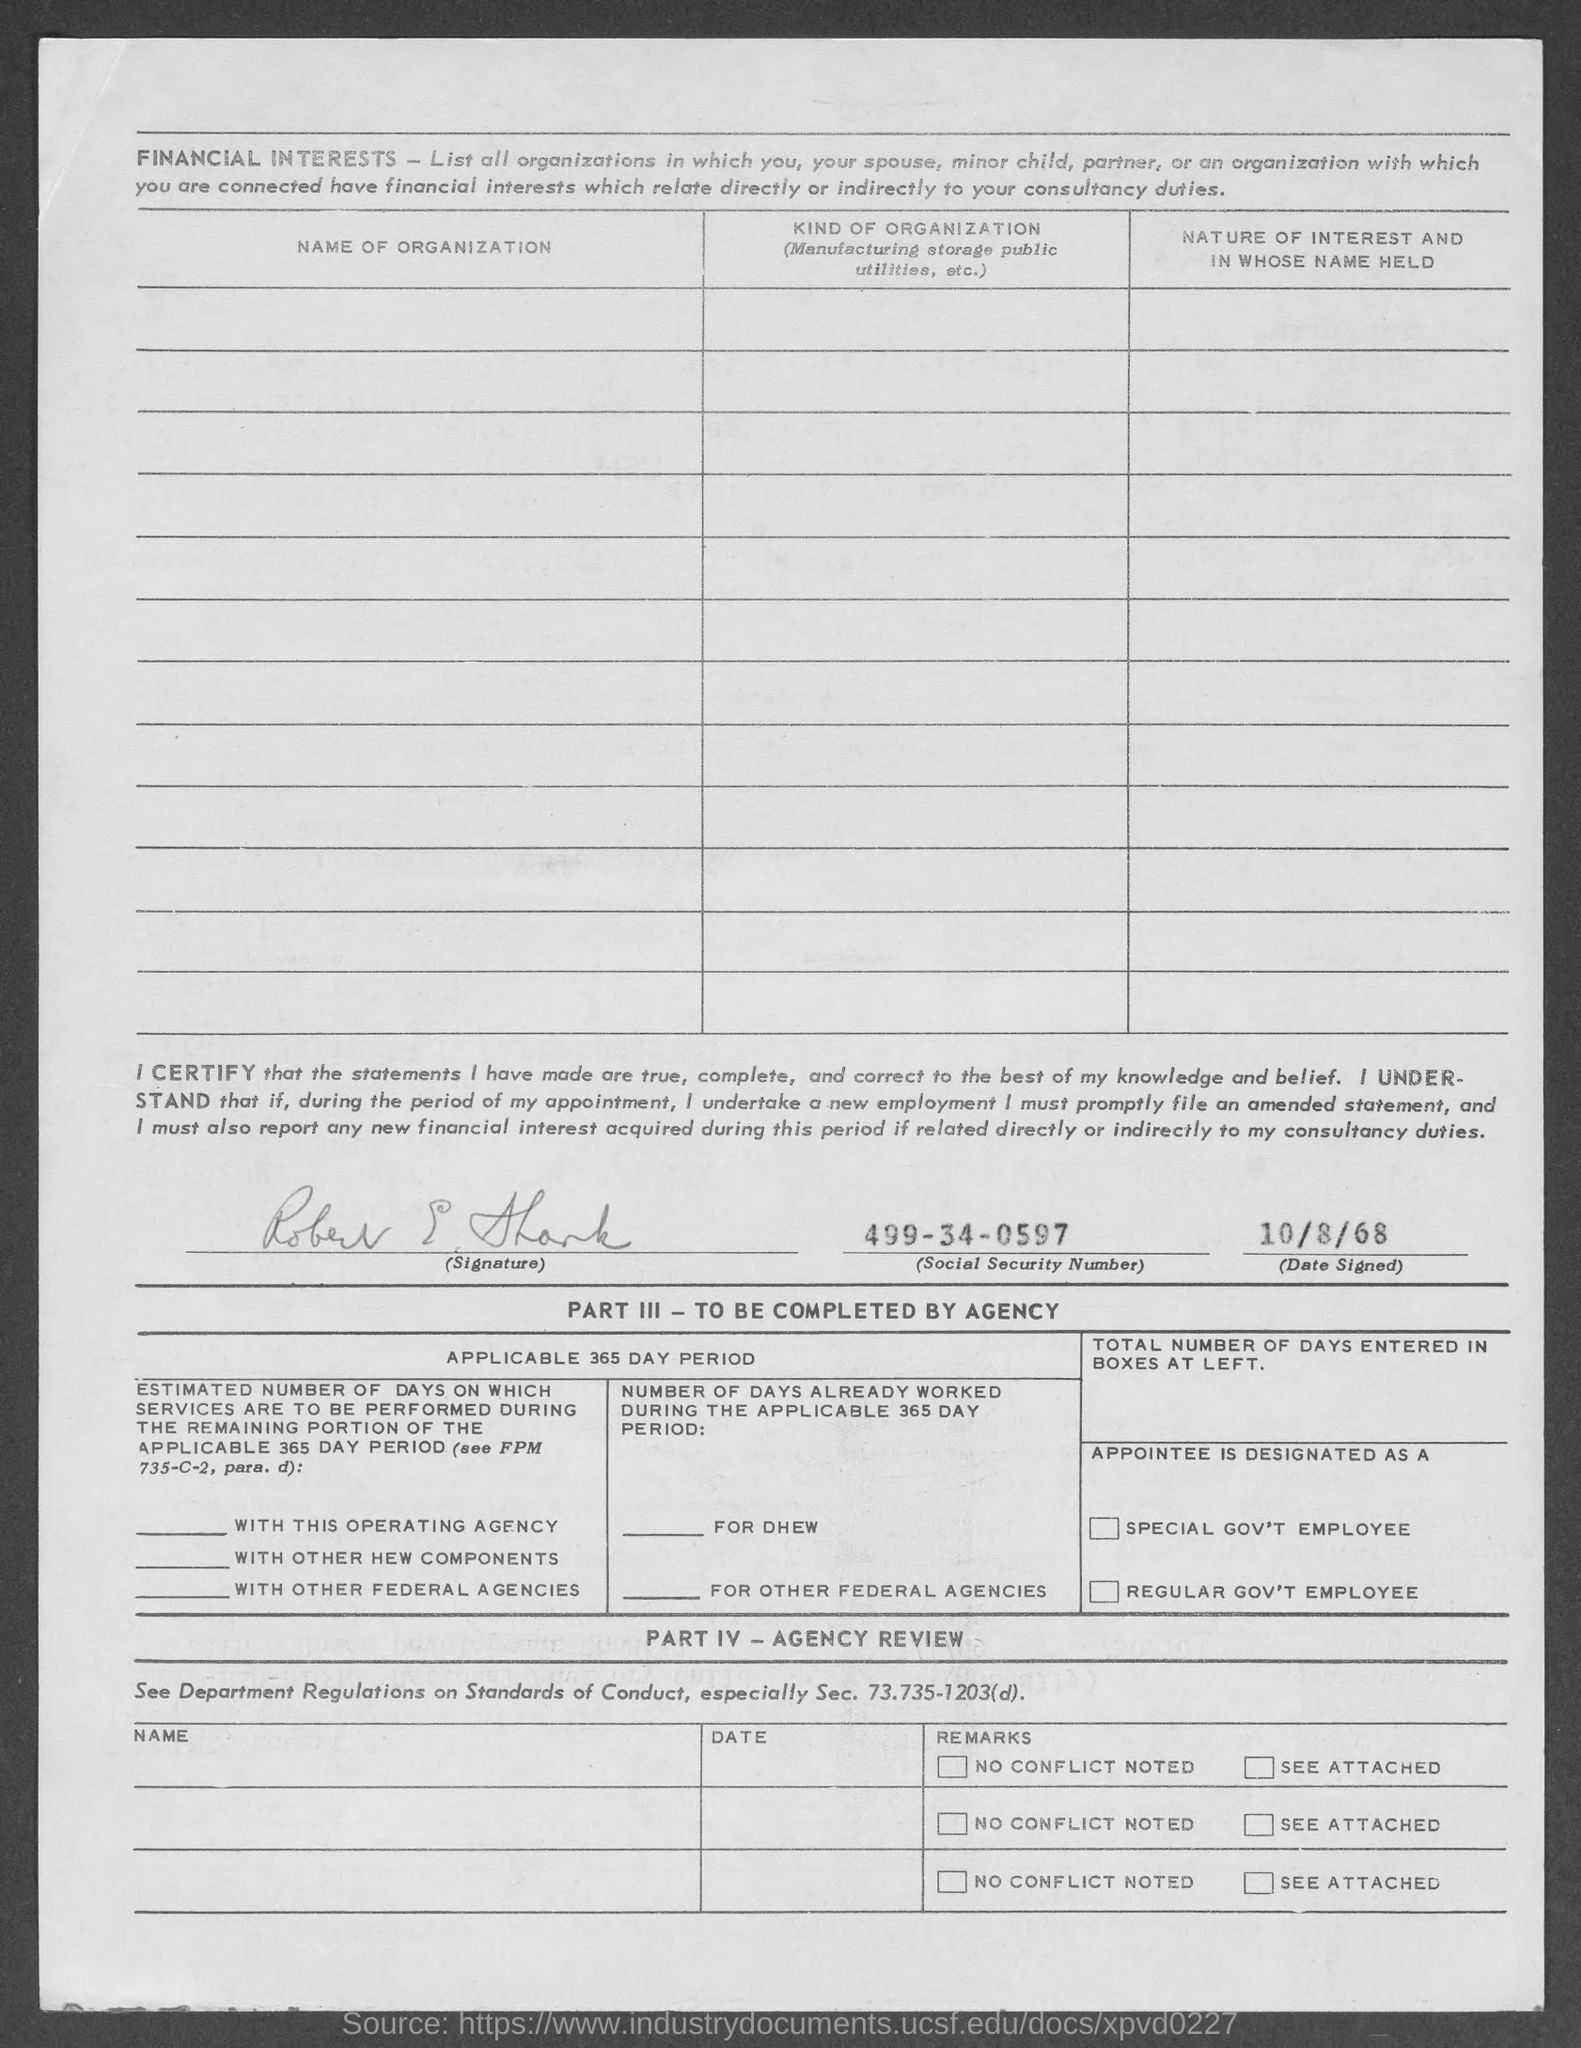What is the social security number given in the document?
Ensure brevity in your answer.  499-34-0597. 